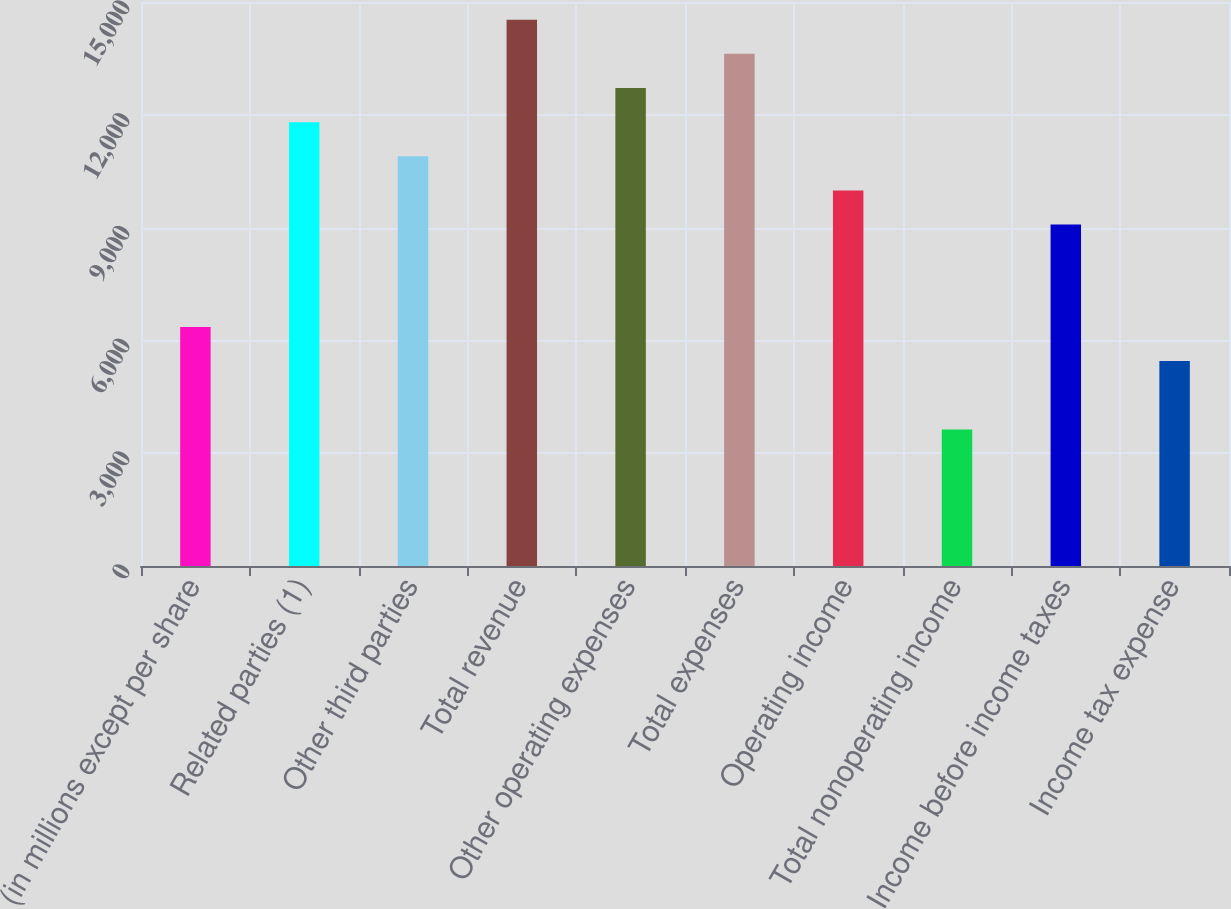Convert chart to OTSL. <chart><loc_0><loc_0><loc_500><loc_500><bar_chart><fcel>(in millions except per share<fcel>Related parties (1)<fcel>Other third parties<fcel>Total revenue<fcel>Other operating expenses<fcel>Total expenses<fcel>Operating income<fcel>Total nonoperating income<fcel>Income before income taxes<fcel>Income tax expense<nl><fcel>6357.3<fcel>11804.7<fcel>10896.8<fcel>14528.4<fcel>12712.6<fcel>13620.5<fcel>9988.9<fcel>3633.6<fcel>9081<fcel>5449.4<nl></chart> 